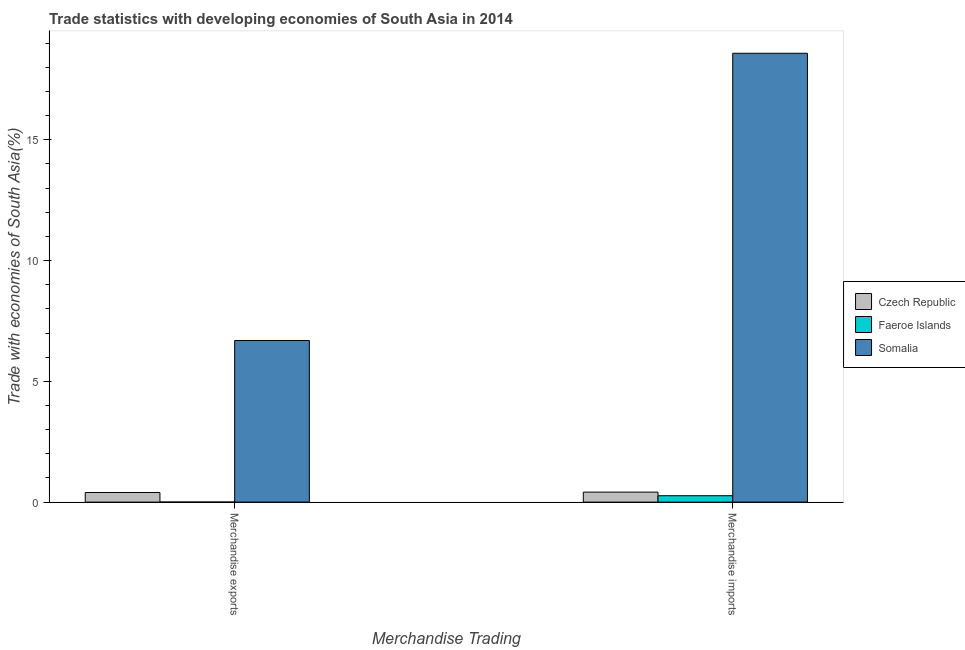How many different coloured bars are there?
Provide a short and direct response. 3. Are the number of bars on each tick of the X-axis equal?
Offer a very short reply. Yes. How many bars are there on the 1st tick from the left?
Provide a succinct answer. 3. How many bars are there on the 1st tick from the right?
Keep it short and to the point. 3. What is the merchandise imports in Somalia?
Make the answer very short. 18.58. Across all countries, what is the maximum merchandise exports?
Make the answer very short. 6.69. Across all countries, what is the minimum merchandise exports?
Offer a terse response. 0. In which country was the merchandise exports maximum?
Offer a terse response. Somalia. In which country was the merchandise exports minimum?
Provide a succinct answer. Faeroe Islands. What is the total merchandise imports in the graph?
Keep it short and to the point. 19.26. What is the difference between the merchandise imports in Somalia and that in Czech Republic?
Provide a succinct answer. 18.17. What is the difference between the merchandise imports in Czech Republic and the merchandise exports in Faeroe Islands?
Give a very brief answer. 0.41. What is the average merchandise imports per country?
Keep it short and to the point. 6.42. What is the difference between the merchandise exports and merchandise imports in Somalia?
Give a very brief answer. -11.89. In how many countries, is the merchandise exports greater than 1 %?
Make the answer very short. 1. What is the ratio of the merchandise imports in Czech Republic to that in Somalia?
Provide a succinct answer. 0.02. Is the merchandise imports in Somalia less than that in Faeroe Islands?
Offer a very short reply. No. In how many countries, is the merchandise imports greater than the average merchandise imports taken over all countries?
Offer a very short reply. 1. What does the 1st bar from the left in Merchandise imports represents?
Provide a short and direct response. Czech Republic. What does the 3rd bar from the right in Merchandise exports represents?
Keep it short and to the point. Czech Republic. How many bars are there?
Your response must be concise. 6. How many countries are there in the graph?
Give a very brief answer. 3. Does the graph contain grids?
Offer a terse response. No. Where does the legend appear in the graph?
Your answer should be very brief. Center right. How many legend labels are there?
Keep it short and to the point. 3. What is the title of the graph?
Offer a terse response. Trade statistics with developing economies of South Asia in 2014. What is the label or title of the X-axis?
Give a very brief answer. Merchandise Trading. What is the label or title of the Y-axis?
Offer a terse response. Trade with economies of South Asia(%). What is the Trade with economies of South Asia(%) in Czech Republic in Merchandise exports?
Provide a short and direct response. 0.4. What is the Trade with economies of South Asia(%) in Faeroe Islands in Merchandise exports?
Your response must be concise. 0. What is the Trade with economies of South Asia(%) in Somalia in Merchandise exports?
Provide a short and direct response. 6.69. What is the Trade with economies of South Asia(%) of Czech Republic in Merchandise imports?
Your answer should be very brief. 0.41. What is the Trade with economies of South Asia(%) of Faeroe Islands in Merchandise imports?
Your response must be concise. 0.26. What is the Trade with economies of South Asia(%) in Somalia in Merchandise imports?
Make the answer very short. 18.58. Across all Merchandise Trading, what is the maximum Trade with economies of South Asia(%) of Czech Republic?
Your answer should be very brief. 0.41. Across all Merchandise Trading, what is the maximum Trade with economies of South Asia(%) of Faeroe Islands?
Your response must be concise. 0.26. Across all Merchandise Trading, what is the maximum Trade with economies of South Asia(%) in Somalia?
Your response must be concise. 18.58. Across all Merchandise Trading, what is the minimum Trade with economies of South Asia(%) of Czech Republic?
Ensure brevity in your answer.  0.4. Across all Merchandise Trading, what is the minimum Trade with economies of South Asia(%) of Faeroe Islands?
Provide a succinct answer. 0. Across all Merchandise Trading, what is the minimum Trade with economies of South Asia(%) of Somalia?
Your answer should be compact. 6.69. What is the total Trade with economies of South Asia(%) of Czech Republic in the graph?
Your answer should be very brief. 0.81. What is the total Trade with economies of South Asia(%) of Faeroe Islands in the graph?
Provide a short and direct response. 0.27. What is the total Trade with economies of South Asia(%) in Somalia in the graph?
Provide a succinct answer. 25.28. What is the difference between the Trade with economies of South Asia(%) in Czech Republic in Merchandise exports and that in Merchandise imports?
Provide a short and direct response. -0.02. What is the difference between the Trade with economies of South Asia(%) in Faeroe Islands in Merchandise exports and that in Merchandise imports?
Provide a succinct answer. -0.26. What is the difference between the Trade with economies of South Asia(%) in Somalia in Merchandise exports and that in Merchandise imports?
Your response must be concise. -11.89. What is the difference between the Trade with economies of South Asia(%) of Czech Republic in Merchandise exports and the Trade with economies of South Asia(%) of Faeroe Islands in Merchandise imports?
Keep it short and to the point. 0.13. What is the difference between the Trade with economies of South Asia(%) of Czech Republic in Merchandise exports and the Trade with economies of South Asia(%) of Somalia in Merchandise imports?
Ensure brevity in your answer.  -18.19. What is the difference between the Trade with economies of South Asia(%) of Faeroe Islands in Merchandise exports and the Trade with economies of South Asia(%) of Somalia in Merchandise imports?
Ensure brevity in your answer.  -18.58. What is the average Trade with economies of South Asia(%) of Czech Republic per Merchandise Trading?
Ensure brevity in your answer.  0.41. What is the average Trade with economies of South Asia(%) in Faeroe Islands per Merchandise Trading?
Offer a very short reply. 0.13. What is the average Trade with economies of South Asia(%) in Somalia per Merchandise Trading?
Make the answer very short. 12.64. What is the difference between the Trade with economies of South Asia(%) of Czech Republic and Trade with economies of South Asia(%) of Faeroe Islands in Merchandise exports?
Your answer should be very brief. 0.4. What is the difference between the Trade with economies of South Asia(%) of Czech Republic and Trade with economies of South Asia(%) of Somalia in Merchandise exports?
Offer a terse response. -6.29. What is the difference between the Trade with economies of South Asia(%) of Faeroe Islands and Trade with economies of South Asia(%) of Somalia in Merchandise exports?
Provide a short and direct response. -6.69. What is the difference between the Trade with economies of South Asia(%) in Czech Republic and Trade with economies of South Asia(%) in Faeroe Islands in Merchandise imports?
Ensure brevity in your answer.  0.15. What is the difference between the Trade with economies of South Asia(%) in Czech Republic and Trade with economies of South Asia(%) in Somalia in Merchandise imports?
Keep it short and to the point. -18.17. What is the difference between the Trade with economies of South Asia(%) in Faeroe Islands and Trade with economies of South Asia(%) in Somalia in Merchandise imports?
Provide a short and direct response. -18.32. What is the ratio of the Trade with economies of South Asia(%) in Czech Republic in Merchandise exports to that in Merchandise imports?
Your response must be concise. 0.96. What is the ratio of the Trade with economies of South Asia(%) of Faeroe Islands in Merchandise exports to that in Merchandise imports?
Keep it short and to the point. 0.01. What is the ratio of the Trade with economies of South Asia(%) in Somalia in Merchandise exports to that in Merchandise imports?
Your response must be concise. 0.36. What is the difference between the highest and the second highest Trade with economies of South Asia(%) in Czech Republic?
Ensure brevity in your answer.  0.02. What is the difference between the highest and the second highest Trade with economies of South Asia(%) of Faeroe Islands?
Offer a very short reply. 0.26. What is the difference between the highest and the second highest Trade with economies of South Asia(%) of Somalia?
Your response must be concise. 11.89. What is the difference between the highest and the lowest Trade with economies of South Asia(%) of Czech Republic?
Offer a terse response. 0.02. What is the difference between the highest and the lowest Trade with economies of South Asia(%) in Faeroe Islands?
Your answer should be very brief. 0.26. What is the difference between the highest and the lowest Trade with economies of South Asia(%) of Somalia?
Ensure brevity in your answer.  11.89. 